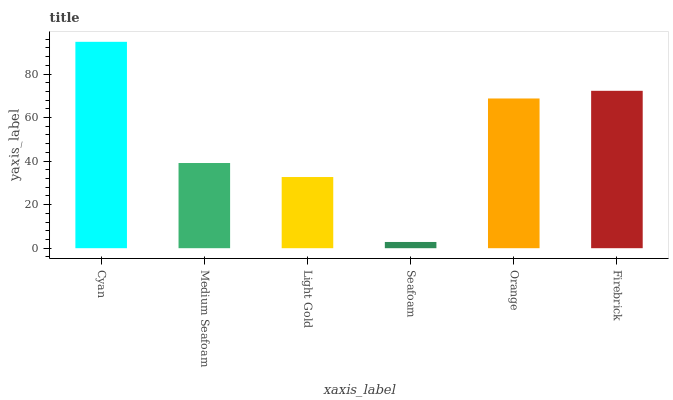Is Medium Seafoam the minimum?
Answer yes or no. No. Is Medium Seafoam the maximum?
Answer yes or no. No. Is Cyan greater than Medium Seafoam?
Answer yes or no. Yes. Is Medium Seafoam less than Cyan?
Answer yes or no. Yes. Is Medium Seafoam greater than Cyan?
Answer yes or no. No. Is Cyan less than Medium Seafoam?
Answer yes or no. No. Is Orange the high median?
Answer yes or no. Yes. Is Medium Seafoam the low median?
Answer yes or no. Yes. Is Light Gold the high median?
Answer yes or no. No. Is Cyan the low median?
Answer yes or no. No. 